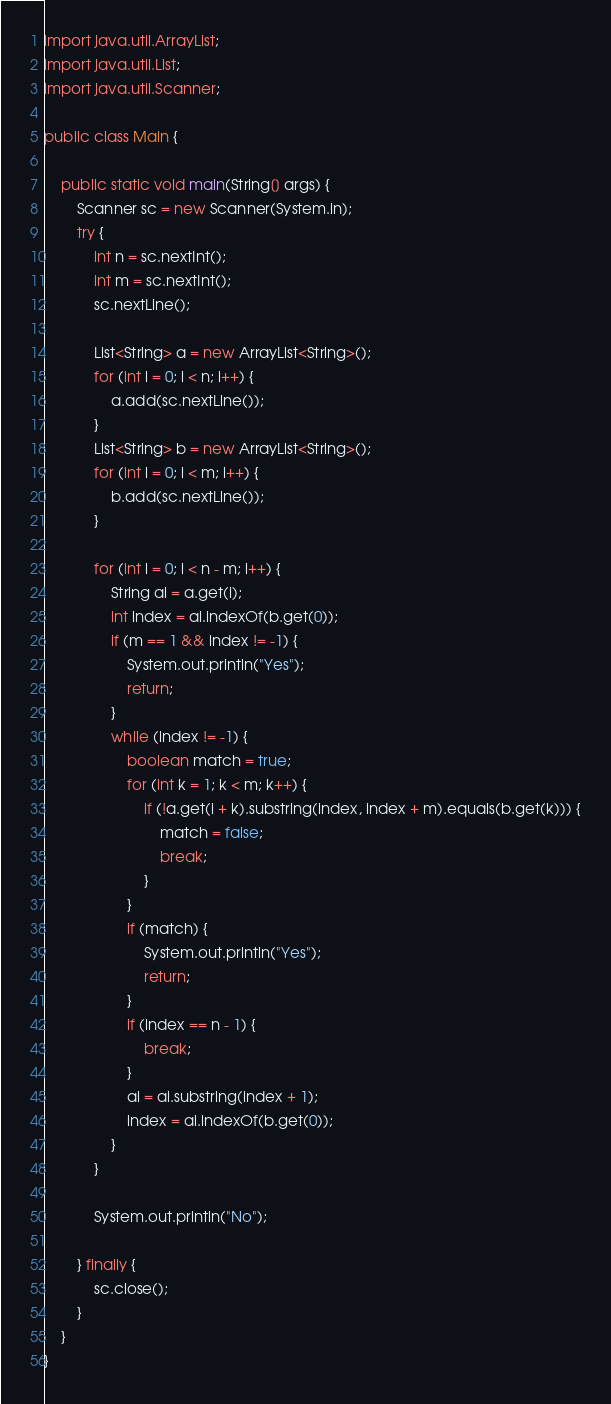<code> <loc_0><loc_0><loc_500><loc_500><_Java_>import java.util.ArrayList;
import java.util.List;
import java.util.Scanner;

public class Main {

	public static void main(String[] args) {
		Scanner sc = new Scanner(System.in);
		try {
			int n = sc.nextInt();
			int m = sc.nextInt();
			sc.nextLine();

			List<String> a = new ArrayList<String>();
			for (int i = 0; i < n; i++) {
				a.add(sc.nextLine());
			}
			List<String> b = new ArrayList<String>();
			for (int i = 0; i < m; i++) {
				b.add(sc.nextLine());
			}

			for (int i = 0; i < n - m; i++) {
				String ai = a.get(i);
				int index = ai.indexOf(b.get(0));
				if (m == 1 && index != -1) {
					System.out.println("Yes");
					return;
				}
				while (index != -1) {
					boolean match = true;
					for (int k = 1; k < m; k++) {
						if (!a.get(i + k).substring(index, index + m).equals(b.get(k))) {
							match = false;
							break;
						}
					}
					if (match) {
						System.out.println("Yes");
						return;
					}
					if (index == n - 1) {
						break;
					}
					ai = ai.substring(index + 1);
					index = ai.indexOf(b.get(0));
				}
			}

			System.out.println("No");

		} finally {
			sc.close();
		}
	}
}</code> 